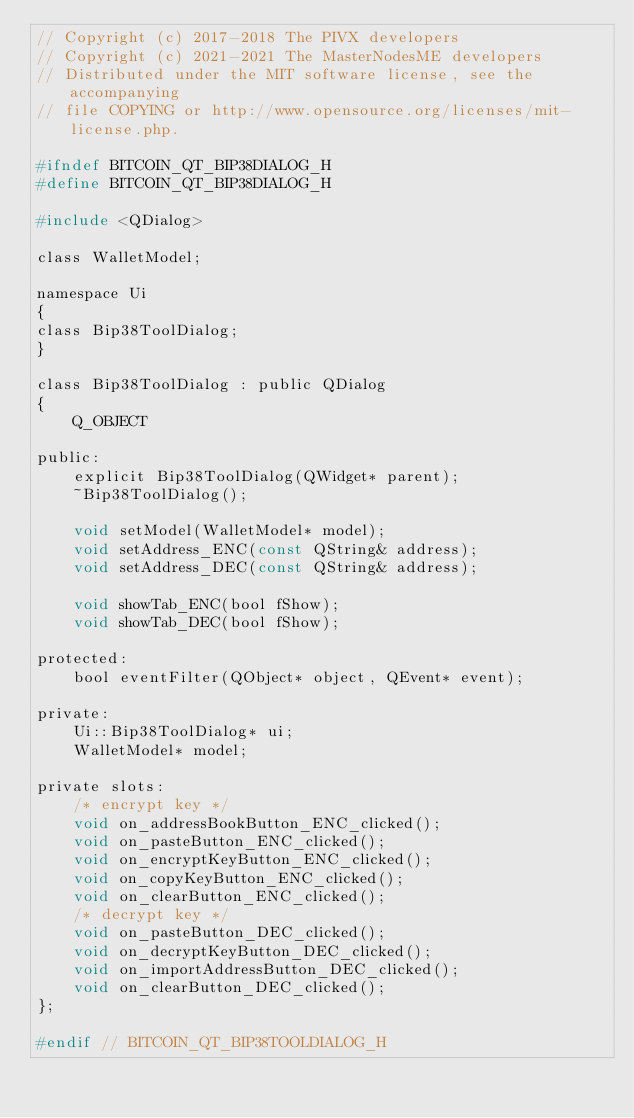Convert code to text. <code><loc_0><loc_0><loc_500><loc_500><_C_>// Copyright (c) 2017-2018 The PIVX developers
// Copyright (c) 2021-2021 The MasterNodesME developers
// Distributed under the MIT software license, see the accompanying
// file COPYING or http://www.opensource.org/licenses/mit-license.php.

#ifndef BITCOIN_QT_BIP38DIALOG_H
#define BITCOIN_QT_BIP38DIALOG_H

#include <QDialog>

class WalletModel;

namespace Ui
{
class Bip38ToolDialog;
}

class Bip38ToolDialog : public QDialog
{
    Q_OBJECT

public:
    explicit Bip38ToolDialog(QWidget* parent);
    ~Bip38ToolDialog();

    void setModel(WalletModel* model);
    void setAddress_ENC(const QString& address);
    void setAddress_DEC(const QString& address);

    void showTab_ENC(bool fShow);
    void showTab_DEC(bool fShow);

protected:
    bool eventFilter(QObject* object, QEvent* event);

private:
    Ui::Bip38ToolDialog* ui;
    WalletModel* model;

private slots:
    /* encrypt key */
    void on_addressBookButton_ENC_clicked();
    void on_pasteButton_ENC_clicked();
    void on_encryptKeyButton_ENC_clicked();
    void on_copyKeyButton_ENC_clicked();
    void on_clearButton_ENC_clicked();
    /* decrypt key */
    void on_pasteButton_DEC_clicked();
    void on_decryptKeyButton_DEC_clicked();
    void on_importAddressButton_DEC_clicked();
    void on_clearButton_DEC_clicked();
};

#endif // BITCOIN_QT_BIP38TOOLDIALOG_H
</code> 